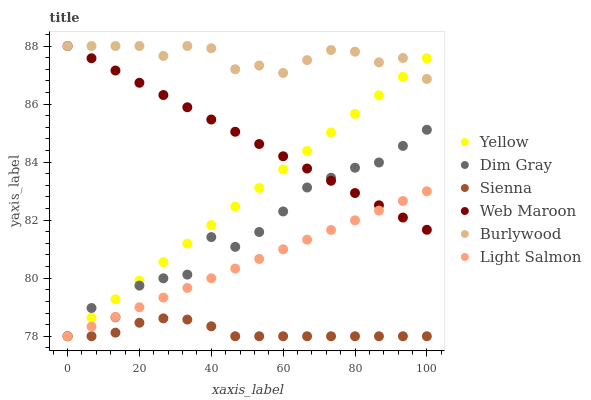Does Sienna have the minimum area under the curve?
Answer yes or no. Yes. Does Burlywood have the maximum area under the curve?
Answer yes or no. Yes. Does Dim Gray have the minimum area under the curve?
Answer yes or no. No. Does Dim Gray have the maximum area under the curve?
Answer yes or no. No. Is Web Maroon the smoothest?
Answer yes or no. Yes. Is Dim Gray the roughest?
Answer yes or no. Yes. Is Burlywood the smoothest?
Answer yes or no. No. Is Burlywood the roughest?
Answer yes or no. No. Does Light Salmon have the lowest value?
Answer yes or no. Yes. Does Burlywood have the lowest value?
Answer yes or no. No. Does Web Maroon have the highest value?
Answer yes or no. Yes. Does Dim Gray have the highest value?
Answer yes or no. No. Is Dim Gray less than Burlywood?
Answer yes or no. Yes. Is Burlywood greater than Sienna?
Answer yes or no. Yes. Does Yellow intersect Web Maroon?
Answer yes or no. Yes. Is Yellow less than Web Maroon?
Answer yes or no. No. Is Yellow greater than Web Maroon?
Answer yes or no. No. Does Dim Gray intersect Burlywood?
Answer yes or no. No. 